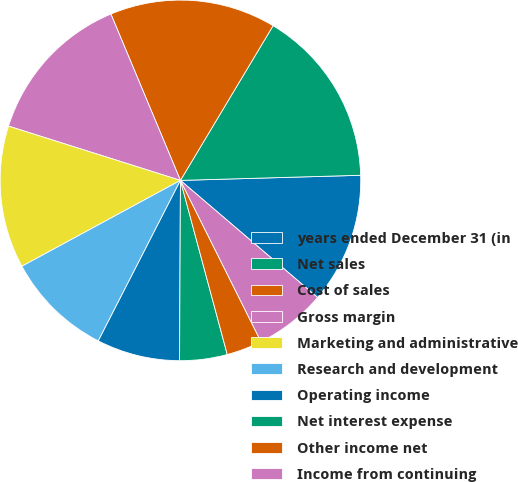Convert chart. <chart><loc_0><loc_0><loc_500><loc_500><pie_chart><fcel>years ended December 31 (in<fcel>Net sales<fcel>Cost of sales<fcel>Gross margin<fcel>Marketing and administrative<fcel>Research and development<fcel>Operating income<fcel>Net interest expense<fcel>Other income net<fcel>Income from continuing<nl><fcel>11.7%<fcel>15.96%<fcel>14.89%<fcel>13.83%<fcel>12.77%<fcel>9.57%<fcel>7.45%<fcel>4.26%<fcel>3.19%<fcel>6.38%<nl></chart> 